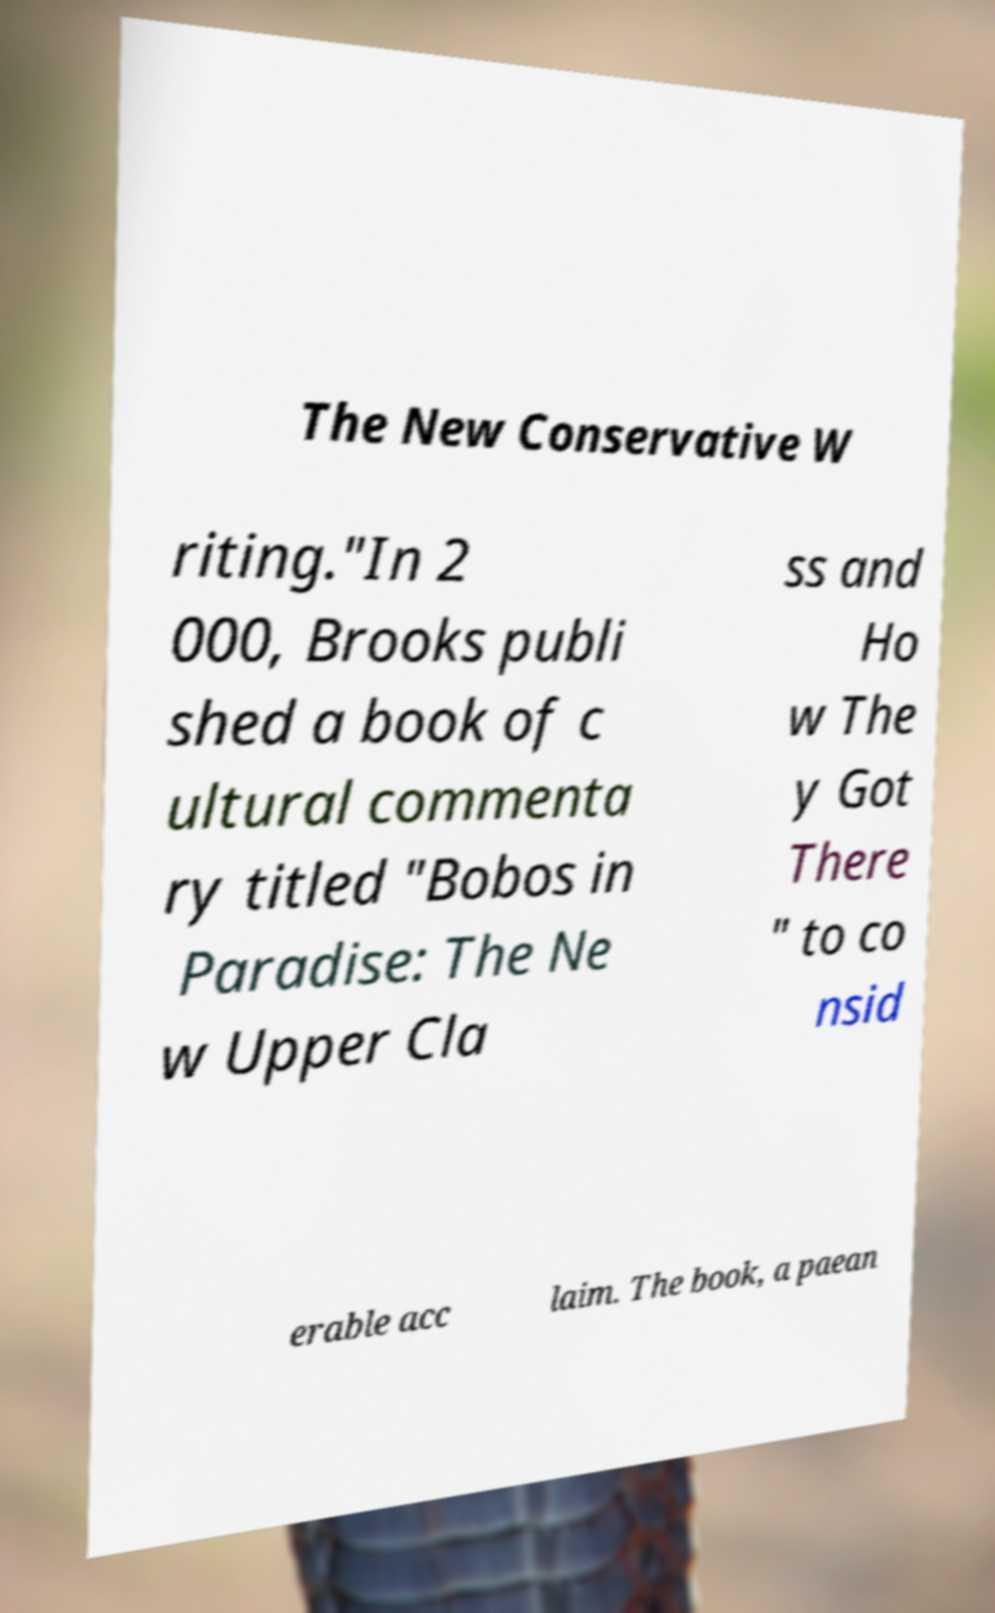Can you accurately transcribe the text from the provided image for me? The New Conservative W riting."In 2 000, Brooks publi shed a book of c ultural commenta ry titled "Bobos in Paradise: The Ne w Upper Cla ss and Ho w The y Got There " to co nsid erable acc laim. The book, a paean 